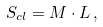<formula> <loc_0><loc_0><loc_500><loc_500>S _ { c l } = M \cdot L \, ,</formula> 